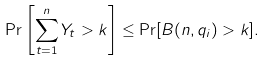Convert formula to latex. <formula><loc_0><loc_0><loc_500><loc_500>\Pr \left [ \sum _ { t = 1 } ^ { n } Y _ { t } > k \right ] \leq \Pr [ B ( n , q _ { i } ) > k ] .</formula> 